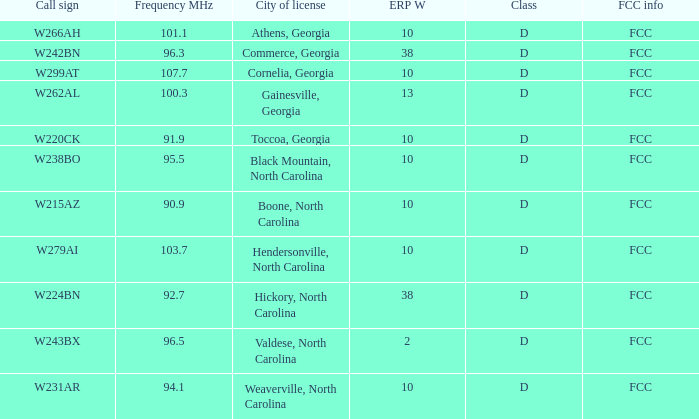1? Athens, Georgia, Commerce, Georgia, Cornelia, Georgia, Gainesville, Georgia, Black Mountain, North Carolina, Hendersonville, North Carolina, Valdese, North Carolina. 